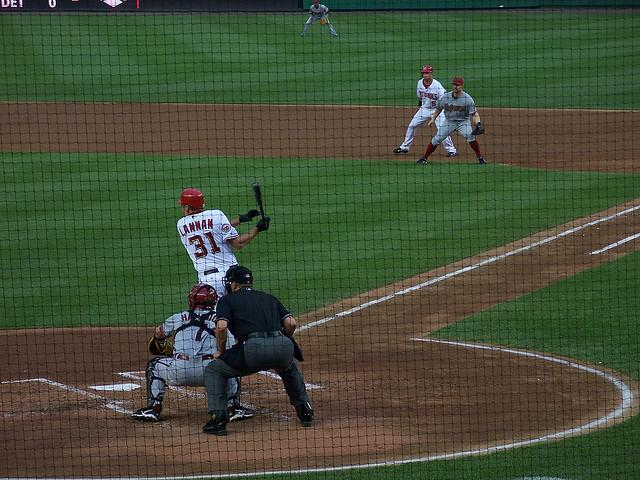What base is the player in white behind the grey suited player supposed to be on? first 